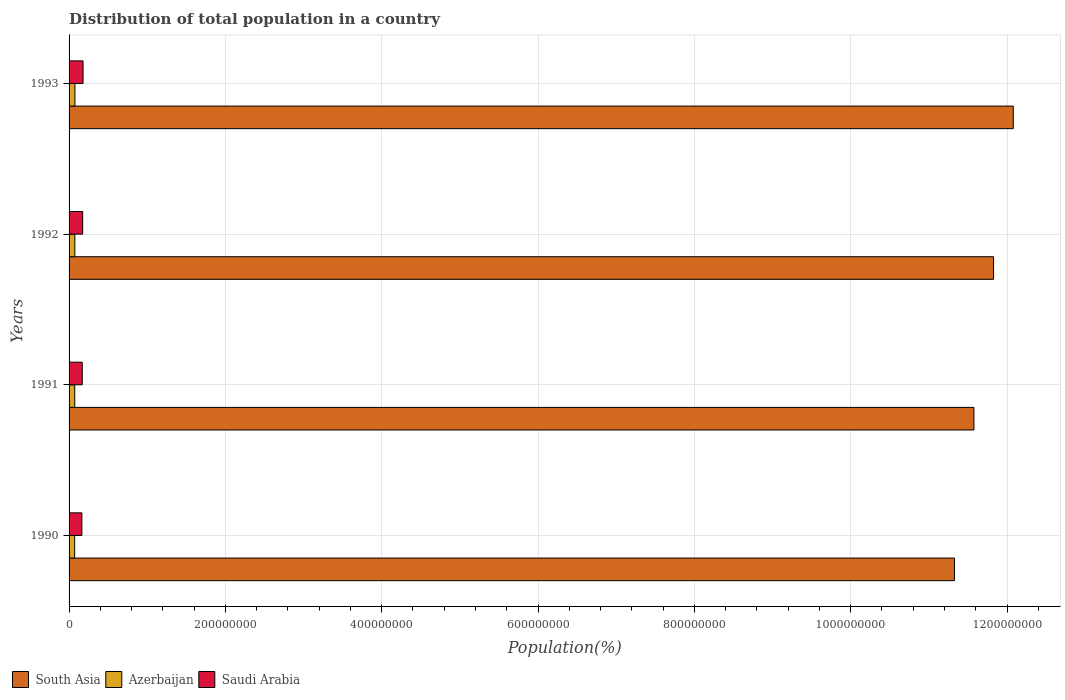How many different coloured bars are there?
Keep it short and to the point. 3. How many groups of bars are there?
Offer a terse response. 4. Are the number of bars per tick equal to the number of legend labels?
Your answer should be compact. Yes. How many bars are there on the 4th tick from the top?
Make the answer very short. 3. How many bars are there on the 2nd tick from the bottom?
Ensure brevity in your answer.  3. What is the label of the 2nd group of bars from the top?
Your answer should be compact. 1992. In how many cases, is the number of bars for a given year not equal to the number of legend labels?
Provide a short and direct response. 0. What is the population of in Saudi Arabia in 1993?
Offer a very short reply. 1.79e+07. Across all years, what is the maximum population of in South Asia?
Provide a succinct answer. 1.21e+09. Across all years, what is the minimum population of in South Asia?
Offer a very short reply. 1.13e+09. What is the total population of in Saudi Arabia in the graph?
Your answer should be compact. 6.85e+07. What is the difference between the population of in Saudi Arabia in 1990 and that in 1991?
Keep it short and to the point. -5.29e+05. What is the difference between the population of in Saudi Arabia in 1992 and the population of in Azerbaijan in 1991?
Your response must be concise. 1.01e+07. What is the average population of in South Asia per year?
Provide a succinct answer. 1.17e+09. In the year 1990, what is the difference between the population of in Saudi Arabia and population of in South Asia?
Your answer should be very brief. -1.12e+09. What is the ratio of the population of in Saudi Arabia in 1992 to that in 1993?
Provide a short and direct response. 0.97. Is the population of in South Asia in 1991 less than that in 1993?
Offer a very short reply. Yes. Is the difference between the population of in Saudi Arabia in 1990 and 1992 greater than the difference between the population of in South Asia in 1990 and 1992?
Your response must be concise. Yes. What is the difference between the highest and the second highest population of in South Asia?
Your answer should be compact. 2.53e+07. What is the difference between the highest and the lowest population of in Azerbaijan?
Make the answer very short. 3.36e+05. Is the sum of the population of in Saudi Arabia in 1991 and 1993 greater than the maximum population of in South Asia across all years?
Make the answer very short. No. What does the 1st bar from the top in 1991 represents?
Provide a succinct answer. Saudi Arabia. What does the 2nd bar from the bottom in 1992 represents?
Provide a succinct answer. Azerbaijan. Is it the case that in every year, the sum of the population of in Azerbaijan and population of in South Asia is greater than the population of in Saudi Arabia?
Give a very brief answer. Yes. How many years are there in the graph?
Keep it short and to the point. 4. How many legend labels are there?
Your answer should be very brief. 3. What is the title of the graph?
Keep it short and to the point. Distribution of total population in a country. Does "Poland" appear as one of the legend labels in the graph?
Offer a very short reply. No. What is the label or title of the X-axis?
Provide a short and direct response. Population(%). What is the label or title of the Y-axis?
Provide a succinct answer. Years. What is the Population(%) of South Asia in 1990?
Your answer should be compact. 1.13e+09. What is the Population(%) in Azerbaijan in 1990?
Offer a terse response. 7.16e+06. What is the Population(%) in Saudi Arabia in 1990?
Offer a terse response. 1.64e+07. What is the Population(%) in South Asia in 1991?
Provide a succinct answer. 1.16e+09. What is the Population(%) in Azerbaijan in 1991?
Your response must be concise. 7.27e+06. What is the Population(%) in Saudi Arabia in 1991?
Give a very brief answer. 1.69e+07. What is the Population(%) of South Asia in 1992?
Keep it short and to the point. 1.18e+09. What is the Population(%) in Azerbaijan in 1992?
Give a very brief answer. 7.38e+06. What is the Population(%) in Saudi Arabia in 1992?
Keep it short and to the point. 1.74e+07. What is the Population(%) in South Asia in 1993?
Give a very brief answer. 1.21e+09. What is the Population(%) in Azerbaijan in 1993?
Offer a terse response. 7.50e+06. What is the Population(%) of Saudi Arabia in 1993?
Provide a succinct answer. 1.79e+07. Across all years, what is the maximum Population(%) of South Asia?
Ensure brevity in your answer.  1.21e+09. Across all years, what is the maximum Population(%) of Azerbaijan?
Offer a very short reply. 7.50e+06. Across all years, what is the maximum Population(%) in Saudi Arabia?
Keep it short and to the point. 1.79e+07. Across all years, what is the minimum Population(%) of South Asia?
Provide a short and direct response. 1.13e+09. Across all years, what is the minimum Population(%) in Azerbaijan?
Your response must be concise. 7.16e+06. Across all years, what is the minimum Population(%) of Saudi Arabia?
Give a very brief answer. 1.64e+07. What is the total Population(%) of South Asia in the graph?
Your answer should be very brief. 4.68e+09. What is the total Population(%) of Azerbaijan in the graph?
Give a very brief answer. 2.93e+07. What is the total Population(%) of Saudi Arabia in the graph?
Your answer should be very brief. 6.85e+07. What is the difference between the Population(%) of South Asia in 1990 and that in 1991?
Give a very brief answer. -2.49e+07. What is the difference between the Population(%) of Azerbaijan in 1990 and that in 1991?
Your answer should be very brief. -1.12e+05. What is the difference between the Population(%) of Saudi Arabia in 1990 and that in 1991?
Your response must be concise. -5.29e+05. What is the difference between the Population(%) in South Asia in 1990 and that in 1992?
Your answer should be compact. -5.00e+07. What is the difference between the Population(%) in Azerbaijan in 1990 and that in 1992?
Provide a succinct answer. -2.23e+05. What is the difference between the Population(%) of Saudi Arabia in 1990 and that in 1992?
Your answer should be compact. -1.04e+06. What is the difference between the Population(%) of South Asia in 1990 and that in 1993?
Keep it short and to the point. -7.53e+07. What is the difference between the Population(%) in Azerbaijan in 1990 and that in 1993?
Provide a succinct answer. -3.36e+05. What is the difference between the Population(%) of Saudi Arabia in 1990 and that in 1993?
Keep it short and to the point. -1.53e+06. What is the difference between the Population(%) in South Asia in 1991 and that in 1992?
Your response must be concise. -2.51e+07. What is the difference between the Population(%) of Azerbaijan in 1991 and that in 1992?
Your answer should be very brief. -1.11e+05. What is the difference between the Population(%) of Saudi Arabia in 1991 and that in 1992?
Keep it short and to the point. -5.08e+05. What is the difference between the Population(%) of South Asia in 1991 and that in 1993?
Your answer should be very brief. -5.03e+07. What is the difference between the Population(%) in Azerbaijan in 1991 and that in 1993?
Offer a very short reply. -2.24e+05. What is the difference between the Population(%) in Saudi Arabia in 1991 and that in 1993?
Give a very brief answer. -1.00e+06. What is the difference between the Population(%) in South Asia in 1992 and that in 1993?
Offer a very short reply. -2.53e+07. What is the difference between the Population(%) in Azerbaijan in 1992 and that in 1993?
Keep it short and to the point. -1.13e+05. What is the difference between the Population(%) in Saudi Arabia in 1992 and that in 1993?
Give a very brief answer. -4.92e+05. What is the difference between the Population(%) in South Asia in 1990 and the Population(%) in Azerbaijan in 1991?
Ensure brevity in your answer.  1.13e+09. What is the difference between the Population(%) of South Asia in 1990 and the Population(%) of Saudi Arabia in 1991?
Your response must be concise. 1.12e+09. What is the difference between the Population(%) in Azerbaijan in 1990 and the Population(%) in Saudi Arabia in 1991?
Provide a succinct answer. -9.73e+06. What is the difference between the Population(%) of South Asia in 1990 and the Population(%) of Azerbaijan in 1992?
Ensure brevity in your answer.  1.13e+09. What is the difference between the Population(%) in South Asia in 1990 and the Population(%) in Saudi Arabia in 1992?
Offer a terse response. 1.12e+09. What is the difference between the Population(%) of Azerbaijan in 1990 and the Population(%) of Saudi Arabia in 1992?
Offer a terse response. -1.02e+07. What is the difference between the Population(%) in South Asia in 1990 and the Population(%) in Azerbaijan in 1993?
Give a very brief answer. 1.13e+09. What is the difference between the Population(%) in South Asia in 1990 and the Population(%) in Saudi Arabia in 1993?
Keep it short and to the point. 1.11e+09. What is the difference between the Population(%) in Azerbaijan in 1990 and the Population(%) in Saudi Arabia in 1993?
Your answer should be compact. -1.07e+07. What is the difference between the Population(%) of South Asia in 1991 and the Population(%) of Azerbaijan in 1992?
Provide a short and direct response. 1.15e+09. What is the difference between the Population(%) of South Asia in 1991 and the Population(%) of Saudi Arabia in 1992?
Your answer should be compact. 1.14e+09. What is the difference between the Population(%) in Azerbaijan in 1991 and the Population(%) in Saudi Arabia in 1992?
Your answer should be compact. -1.01e+07. What is the difference between the Population(%) of South Asia in 1991 and the Population(%) of Azerbaijan in 1993?
Offer a terse response. 1.15e+09. What is the difference between the Population(%) of South Asia in 1991 and the Population(%) of Saudi Arabia in 1993?
Give a very brief answer. 1.14e+09. What is the difference between the Population(%) in Azerbaijan in 1991 and the Population(%) in Saudi Arabia in 1993?
Keep it short and to the point. -1.06e+07. What is the difference between the Population(%) in South Asia in 1992 and the Population(%) in Azerbaijan in 1993?
Provide a succinct answer. 1.18e+09. What is the difference between the Population(%) in South Asia in 1992 and the Population(%) in Saudi Arabia in 1993?
Give a very brief answer. 1.16e+09. What is the difference between the Population(%) of Azerbaijan in 1992 and the Population(%) of Saudi Arabia in 1993?
Make the answer very short. -1.05e+07. What is the average Population(%) in South Asia per year?
Your response must be concise. 1.17e+09. What is the average Population(%) in Azerbaijan per year?
Offer a very short reply. 7.33e+06. What is the average Population(%) of Saudi Arabia per year?
Provide a short and direct response. 1.71e+07. In the year 1990, what is the difference between the Population(%) of South Asia and Population(%) of Azerbaijan?
Provide a succinct answer. 1.13e+09. In the year 1990, what is the difference between the Population(%) in South Asia and Population(%) in Saudi Arabia?
Your answer should be compact. 1.12e+09. In the year 1990, what is the difference between the Population(%) in Azerbaijan and Population(%) in Saudi Arabia?
Your answer should be very brief. -9.20e+06. In the year 1991, what is the difference between the Population(%) of South Asia and Population(%) of Azerbaijan?
Offer a very short reply. 1.15e+09. In the year 1991, what is the difference between the Population(%) of South Asia and Population(%) of Saudi Arabia?
Offer a very short reply. 1.14e+09. In the year 1991, what is the difference between the Population(%) in Azerbaijan and Population(%) in Saudi Arabia?
Give a very brief answer. -9.62e+06. In the year 1992, what is the difference between the Population(%) in South Asia and Population(%) in Azerbaijan?
Offer a very short reply. 1.18e+09. In the year 1992, what is the difference between the Population(%) of South Asia and Population(%) of Saudi Arabia?
Ensure brevity in your answer.  1.17e+09. In the year 1992, what is the difference between the Population(%) in Azerbaijan and Population(%) in Saudi Arabia?
Provide a succinct answer. -1.00e+07. In the year 1993, what is the difference between the Population(%) of South Asia and Population(%) of Azerbaijan?
Provide a short and direct response. 1.20e+09. In the year 1993, what is the difference between the Population(%) of South Asia and Population(%) of Saudi Arabia?
Ensure brevity in your answer.  1.19e+09. In the year 1993, what is the difference between the Population(%) in Azerbaijan and Population(%) in Saudi Arabia?
Ensure brevity in your answer.  -1.04e+07. What is the ratio of the Population(%) in South Asia in 1990 to that in 1991?
Offer a terse response. 0.98. What is the ratio of the Population(%) in Azerbaijan in 1990 to that in 1991?
Your answer should be very brief. 0.98. What is the ratio of the Population(%) in Saudi Arabia in 1990 to that in 1991?
Give a very brief answer. 0.97. What is the ratio of the Population(%) in South Asia in 1990 to that in 1992?
Keep it short and to the point. 0.96. What is the ratio of the Population(%) in Azerbaijan in 1990 to that in 1992?
Offer a very short reply. 0.97. What is the ratio of the Population(%) in Saudi Arabia in 1990 to that in 1992?
Ensure brevity in your answer.  0.94. What is the ratio of the Population(%) of South Asia in 1990 to that in 1993?
Your answer should be very brief. 0.94. What is the ratio of the Population(%) of Azerbaijan in 1990 to that in 1993?
Ensure brevity in your answer.  0.96. What is the ratio of the Population(%) in Saudi Arabia in 1990 to that in 1993?
Make the answer very short. 0.91. What is the ratio of the Population(%) of South Asia in 1991 to that in 1992?
Ensure brevity in your answer.  0.98. What is the ratio of the Population(%) of Azerbaijan in 1991 to that in 1992?
Offer a terse response. 0.98. What is the ratio of the Population(%) in Saudi Arabia in 1991 to that in 1992?
Ensure brevity in your answer.  0.97. What is the ratio of the Population(%) of South Asia in 1991 to that in 1993?
Your response must be concise. 0.96. What is the ratio of the Population(%) of Azerbaijan in 1991 to that in 1993?
Make the answer very short. 0.97. What is the ratio of the Population(%) in Saudi Arabia in 1991 to that in 1993?
Keep it short and to the point. 0.94. What is the ratio of the Population(%) in South Asia in 1992 to that in 1993?
Your answer should be compact. 0.98. What is the ratio of the Population(%) of Azerbaijan in 1992 to that in 1993?
Give a very brief answer. 0.98. What is the ratio of the Population(%) of Saudi Arabia in 1992 to that in 1993?
Make the answer very short. 0.97. What is the difference between the highest and the second highest Population(%) of South Asia?
Offer a terse response. 2.53e+07. What is the difference between the highest and the second highest Population(%) of Azerbaijan?
Make the answer very short. 1.13e+05. What is the difference between the highest and the second highest Population(%) in Saudi Arabia?
Your answer should be compact. 4.92e+05. What is the difference between the highest and the lowest Population(%) in South Asia?
Offer a terse response. 7.53e+07. What is the difference between the highest and the lowest Population(%) of Azerbaijan?
Keep it short and to the point. 3.36e+05. What is the difference between the highest and the lowest Population(%) of Saudi Arabia?
Give a very brief answer. 1.53e+06. 